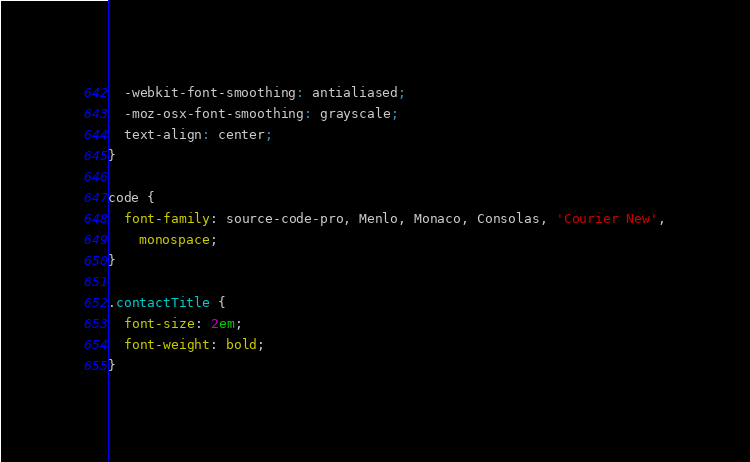Convert code to text. <code><loc_0><loc_0><loc_500><loc_500><_CSS_>  -webkit-font-smoothing: antialiased;
  -moz-osx-font-smoothing: grayscale;
  text-align: center;
}

code {
  font-family: source-code-pro, Menlo, Monaco, Consolas, 'Courier New',
    monospace;
}

.contactTitle {
  font-size: 2em;
  font-weight: bold;
}
</code> 